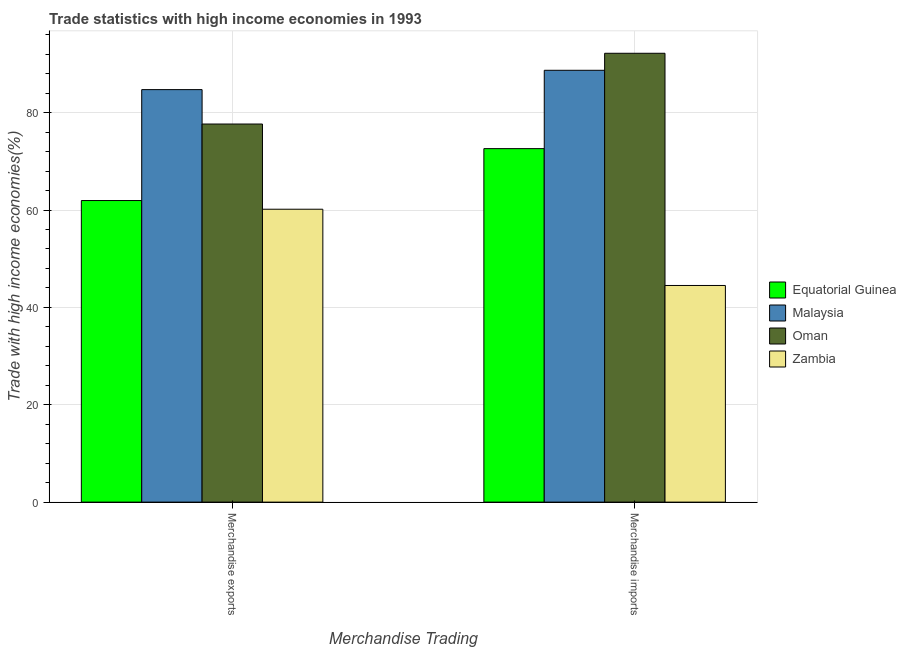Are the number of bars on each tick of the X-axis equal?
Ensure brevity in your answer.  Yes. What is the merchandise exports in Zambia?
Your response must be concise. 60.16. Across all countries, what is the maximum merchandise exports?
Your answer should be compact. 84.73. Across all countries, what is the minimum merchandise exports?
Give a very brief answer. 60.16. In which country was the merchandise imports maximum?
Offer a very short reply. Oman. In which country was the merchandise exports minimum?
Your answer should be compact. Zambia. What is the total merchandise exports in the graph?
Keep it short and to the point. 284.49. What is the difference between the merchandise exports in Zambia and that in Malaysia?
Keep it short and to the point. -24.57. What is the difference between the merchandise exports in Zambia and the merchandise imports in Malaysia?
Make the answer very short. -28.54. What is the average merchandise exports per country?
Keep it short and to the point. 71.12. What is the difference between the merchandise exports and merchandise imports in Oman?
Offer a terse response. -14.53. What is the ratio of the merchandise imports in Equatorial Guinea to that in Oman?
Provide a succinct answer. 0.79. Is the merchandise exports in Equatorial Guinea less than that in Malaysia?
Your answer should be very brief. Yes. What does the 4th bar from the left in Merchandise imports represents?
Keep it short and to the point. Zambia. What does the 2nd bar from the right in Merchandise imports represents?
Offer a very short reply. Oman. Are all the bars in the graph horizontal?
Your response must be concise. No. How many countries are there in the graph?
Offer a terse response. 4. What is the difference between two consecutive major ticks on the Y-axis?
Your answer should be very brief. 20. Are the values on the major ticks of Y-axis written in scientific E-notation?
Your answer should be compact. No. Does the graph contain grids?
Ensure brevity in your answer.  Yes. Where does the legend appear in the graph?
Your answer should be very brief. Center right. What is the title of the graph?
Make the answer very short. Trade statistics with high income economies in 1993. What is the label or title of the X-axis?
Your answer should be compact. Merchandise Trading. What is the label or title of the Y-axis?
Your answer should be very brief. Trade with high income economies(%). What is the Trade with high income economies(%) in Equatorial Guinea in Merchandise exports?
Offer a terse response. 61.94. What is the Trade with high income economies(%) in Malaysia in Merchandise exports?
Your answer should be very brief. 84.73. What is the Trade with high income economies(%) of Oman in Merchandise exports?
Provide a succinct answer. 77.66. What is the Trade with high income economies(%) in Zambia in Merchandise exports?
Offer a terse response. 60.16. What is the Trade with high income economies(%) in Equatorial Guinea in Merchandise imports?
Your answer should be very brief. 72.6. What is the Trade with high income economies(%) of Malaysia in Merchandise imports?
Keep it short and to the point. 88.7. What is the Trade with high income economies(%) of Oman in Merchandise imports?
Offer a terse response. 92.19. What is the Trade with high income economies(%) in Zambia in Merchandise imports?
Keep it short and to the point. 44.5. Across all Merchandise Trading, what is the maximum Trade with high income economies(%) of Equatorial Guinea?
Offer a terse response. 72.6. Across all Merchandise Trading, what is the maximum Trade with high income economies(%) in Malaysia?
Your answer should be very brief. 88.7. Across all Merchandise Trading, what is the maximum Trade with high income economies(%) of Oman?
Your answer should be compact. 92.19. Across all Merchandise Trading, what is the maximum Trade with high income economies(%) of Zambia?
Keep it short and to the point. 60.16. Across all Merchandise Trading, what is the minimum Trade with high income economies(%) in Equatorial Guinea?
Keep it short and to the point. 61.94. Across all Merchandise Trading, what is the minimum Trade with high income economies(%) in Malaysia?
Give a very brief answer. 84.73. Across all Merchandise Trading, what is the minimum Trade with high income economies(%) of Oman?
Your response must be concise. 77.66. Across all Merchandise Trading, what is the minimum Trade with high income economies(%) of Zambia?
Give a very brief answer. 44.5. What is the total Trade with high income economies(%) of Equatorial Guinea in the graph?
Give a very brief answer. 134.55. What is the total Trade with high income economies(%) in Malaysia in the graph?
Provide a short and direct response. 173.42. What is the total Trade with high income economies(%) of Oman in the graph?
Provide a succinct answer. 169.85. What is the total Trade with high income economies(%) in Zambia in the graph?
Ensure brevity in your answer.  104.66. What is the difference between the Trade with high income economies(%) in Equatorial Guinea in Merchandise exports and that in Merchandise imports?
Provide a succinct answer. -10.66. What is the difference between the Trade with high income economies(%) of Malaysia in Merchandise exports and that in Merchandise imports?
Offer a very short reply. -3.97. What is the difference between the Trade with high income economies(%) of Oman in Merchandise exports and that in Merchandise imports?
Keep it short and to the point. -14.53. What is the difference between the Trade with high income economies(%) in Zambia in Merchandise exports and that in Merchandise imports?
Your response must be concise. 15.66. What is the difference between the Trade with high income economies(%) in Equatorial Guinea in Merchandise exports and the Trade with high income economies(%) in Malaysia in Merchandise imports?
Give a very brief answer. -26.75. What is the difference between the Trade with high income economies(%) of Equatorial Guinea in Merchandise exports and the Trade with high income economies(%) of Oman in Merchandise imports?
Your answer should be very brief. -30.25. What is the difference between the Trade with high income economies(%) in Equatorial Guinea in Merchandise exports and the Trade with high income economies(%) in Zambia in Merchandise imports?
Offer a terse response. 17.45. What is the difference between the Trade with high income economies(%) in Malaysia in Merchandise exports and the Trade with high income economies(%) in Oman in Merchandise imports?
Make the answer very short. -7.46. What is the difference between the Trade with high income economies(%) of Malaysia in Merchandise exports and the Trade with high income economies(%) of Zambia in Merchandise imports?
Provide a succinct answer. 40.23. What is the difference between the Trade with high income economies(%) of Oman in Merchandise exports and the Trade with high income economies(%) of Zambia in Merchandise imports?
Ensure brevity in your answer.  33.16. What is the average Trade with high income economies(%) in Equatorial Guinea per Merchandise Trading?
Your answer should be compact. 67.27. What is the average Trade with high income economies(%) in Malaysia per Merchandise Trading?
Offer a terse response. 86.71. What is the average Trade with high income economies(%) of Oman per Merchandise Trading?
Keep it short and to the point. 84.92. What is the average Trade with high income economies(%) in Zambia per Merchandise Trading?
Your answer should be very brief. 52.33. What is the difference between the Trade with high income economies(%) of Equatorial Guinea and Trade with high income economies(%) of Malaysia in Merchandise exports?
Give a very brief answer. -22.78. What is the difference between the Trade with high income economies(%) in Equatorial Guinea and Trade with high income economies(%) in Oman in Merchandise exports?
Keep it short and to the point. -15.71. What is the difference between the Trade with high income economies(%) of Equatorial Guinea and Trade with high income economies(%) of Zambia in Merchandise exports?
Give a very brief answer. 1.78. What is the difference between the Trade with high income economies(%) in Malaysia and Trade with high income economies(%) in Oman in Merchandise exports?
Make the answer very short. 7.07. What is the difference between the Trade with high income economies(%) in Malaysia and Trade with high income economies(%) in Zambia in Merchandise exports?
Your response must be concise. 24.57. What is the difference between the Trade with high income economies(%) in Oman and Trade with high income economies(%) in Zambia in Merchandise exports?
Give a very brief answer. 17.5. What is the difference between the Trade with high income economies(%) in Equatorial Guinea and Trade with high income economies(%) in Malaysia in Merchandise imports?
Make the answer very short. -16.09. What is the difference between the Trade with high income economies(%) in Equatorial Guinea and Trade with high income economies(%) in Oman in Merchandise imports?
Offer a very short reply. -19.59. What is the difference between the Trade with high income economies(%) in Equatorial Guinea and Trade with high income economies(%) in Zambia in Merchandise imports?
Your answer should be compact. 28.11. What is the difference between the Trade with high income economies(%) in Malaysia and Trade with high income economies(%) in Oman in Merchandise imports?
Provide a succinct answer. -3.5. What is the difference between the Trade with high income economies(%) in Malaysia and Trade with high income economies(%) in Zambia in Merchandise imports?
Provide a succinct answer. 44.2. What is the difference between the Trade with high income economies(%) of Oman and Trade with high income economies(%) of Zambia in Merchandise imports?
Keep it short and to the point. 47.7. What is the ratio of the Trade with high income economies(%) of Equatorial Guinea in Merchandise exports to that in Merchandise imports?
Provide a succinct answer. 0.85. What is the ratio of the Trade with high income economies(%) of Malaysia in Merchandise exports to that in Merchandise imports?
Your answer should be compact. 0.96. What is the ratio of the Trade with high income economies(%) of Oman in Merchandise exports to that in Merchandise imports?
Offer a very short reply. 0.84. What is the ratio of the Trade with high income economies(%) of Zambia in Merchandise exports to that in Merchandise imports?
Provide a short and direct response. 1.35. What is the difference between the highest and the second highest Trade with high income economies(%) in Equatorial Guinea?
Provide a succinct answer. 10.66. What is the difference between the highest and the second highest Trade with high income economies(%) in Malaysia?
Keep it short and to the point. 3.97. What is the difference between the highest and the second highest Trade with high income economies(%) in Oman?
Your answer should be compact. 14.53. What is the difference between the highest and the second highest Trade with high income economies(%) in Zambia?
Give a very brief answer. 15.66. What is the difference between the highest and the lowest Trade with high income economies(%) of Equatorial Guinea?
Give a very brief answer. 10.66. What is the difference between the highest and the lowest Trade with high income economies(%) in Malaysia?
Your answer should be very brief. 3.97. What is the difference between the highest and the lowest Trade with high income economies(%) of Oman?
Ensure brevity in your answer.  14.53. What is the difference between the highest and the lowest Trade with high income economies(%) in Zambia?
Keep it short and to the point. 15.66. 